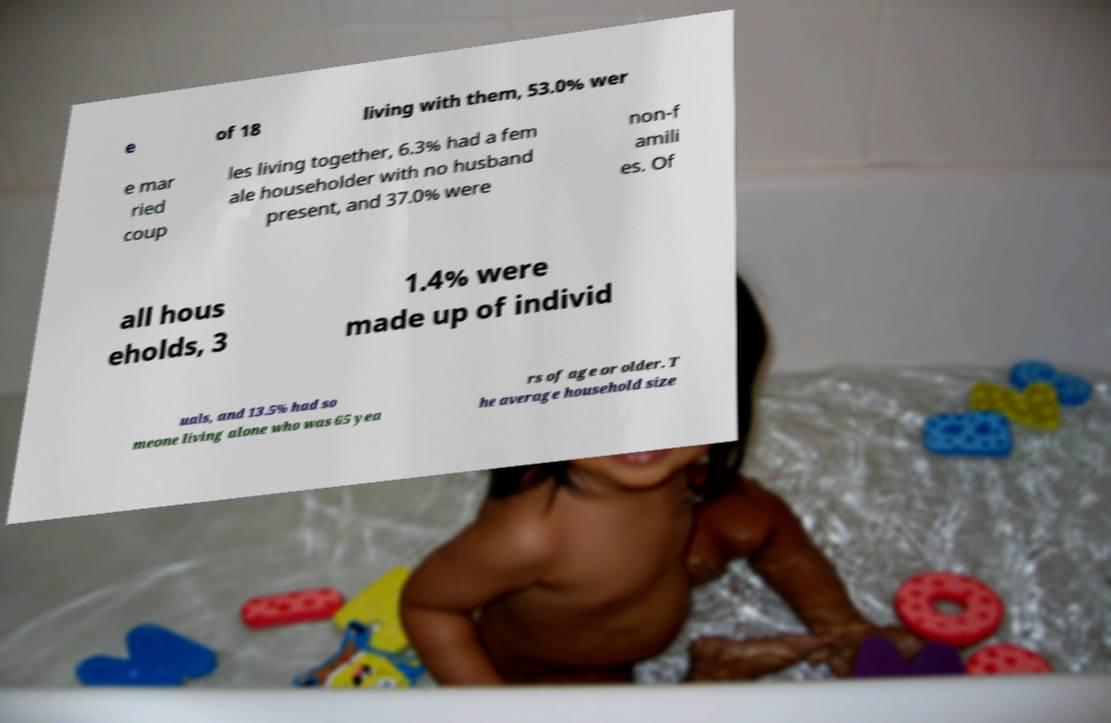Please identify and transcribe the text found in this image. e of 18 living with them, 53.0% wer e mar ried coup les living together, 6.3% had a fem ale householder with no husband present, and 37.0% were non-f amili es. Of all hous eholds, 3 1.4% were made up of individ uals, and 13.5% had so meone living alone who was 65 yea rs of age or older. T he average household size 